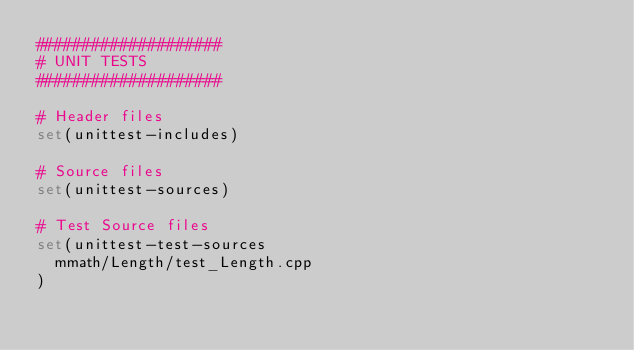<code> <loc_0><loc_0><loc_500><loc_500><_CMake_>####################
# UNIT TESTS
####################

# Header files
set(unittest-includes)

# Source files
set(unittest-sources)

# Test Source files
set(unittest-test-sources
  mmath/Length/test_Length.cpp
)
</code> 